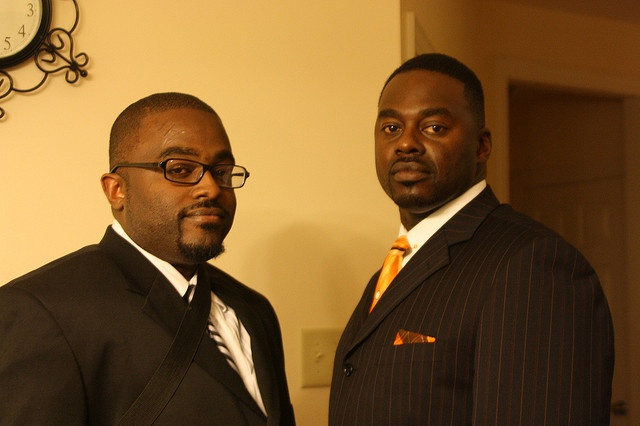Describe the objects in this image and their specific colors. I can see people in tan, black, maroon, and brown tones, people in tan, black, brown, and maroon tones, clock in tan and black tones, tie in tan, orange, red, maroon, and gold tones, and tie in tan, black, gray, and maroon tones in this image. 